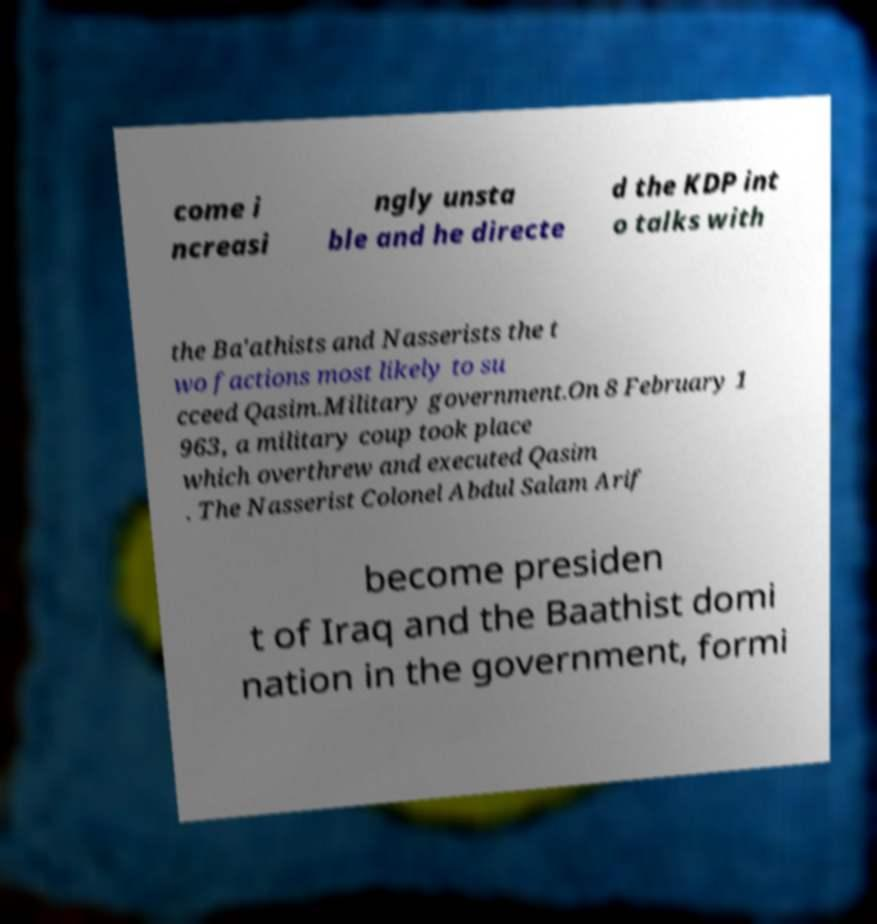Can you accurately transcribe the text from the provided image for me? come i ncreasi ngly unsta ble and he directe d the KDP int o talks with the Ba'athists and Nasserists the t wo factions most likely to su cceed Qasim.Military government.On 8 February 1 963, a military coup took place which overthrew and executed Qasim . The Nasserist Colonel Abdul Salam Arif become presiden t of Iraq and the Baathist domi nation in the government, formi 